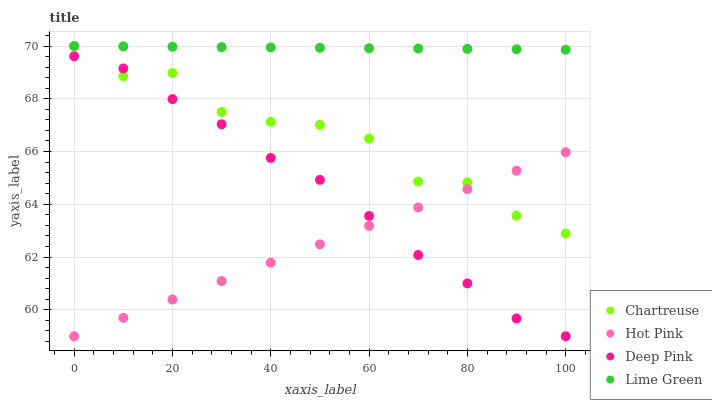Does Hot Pink have the minimum area under the curve?
Answer yes or no. Yes. Does Lime Green have the maximum area under the curve?
Answer yes or no. Yes. Does Lime Green have the minimum area under the curve?
Answer yes or no. No. Does Hot Pink have the maximum area under the curve?
Answer yes or no. No. Is Hot Pink the smoothest?
Answer yes or no. Yes. Is Chartreuse the roughest?
Answer yes or no. Yes. Is Lime Green the smoothest?
Answer yes or no. No. Is Lime Green the roughest?
Answer yes or no. No. Does Hot Pink have the lowest value?
Answer yes or no. Yes. Does Lime Green have the lowest value?
Answer yes or no. No. Does Lime Green have the highest value?
Answer yes or no. Yes. Does Hot Pink have the highest value?
Answer yes or no. No. Is Deep Pink less than Lime Green?
Answer yes or no. Yes. Is Lime Green greater than Hot Pink?
Answer yes or no. Yes. Does Chartreuse intersect Deep Pink?
Answer yes or no. Yes. Is Chartreuse less than Deep Pink?
Answer yes or no. No. Is Chartreuse greater than Deep Pink?
Answer yes or no. No. Does Deep Pink intersect Lime Green?
Answer yes or no. No. 